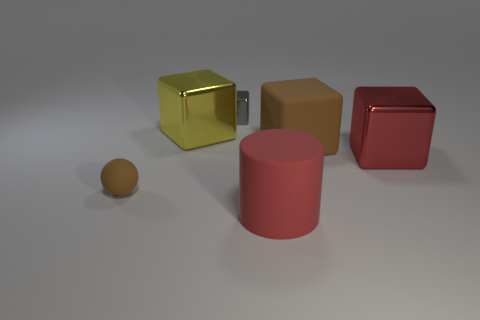How many other blocks have the same color as the large rubber cube?
Offer a very short reply. 0. Do the gray object and the big brown rubber object have the same shape?
Give a very brief answer. Yes. Are there any other things that are the same size as the brown matte ball?
Offer a terse response. Yes. The other yellow object that is the same shape as the tiny metal thing is what size?
Your answer should be compact. Large. Are there more small rubber balls in front of the big cylinder than red matte objects behind the brown matte ball?
Give a very brief answer. No. Is the red block made of the same material as the tiny thing that is left of the tiny block?
Your answer should be very brief. No. Is there anything else that has the same shape as the small gray thing?
Make the answer very short. Yes. The object that is in front of the tiny metallic block and behind the big brown matte object is what color?
Your response must be concise. Yellow. There is a tiny thing to the left of the tiny gray cube; what is its shape?
Ensure brevity in your answer.  Sphere. What is the size of the cube that is on the left side of the shiny block behind the yellow block that is right of the small matte object?
Provide a short and direct response. Large. 